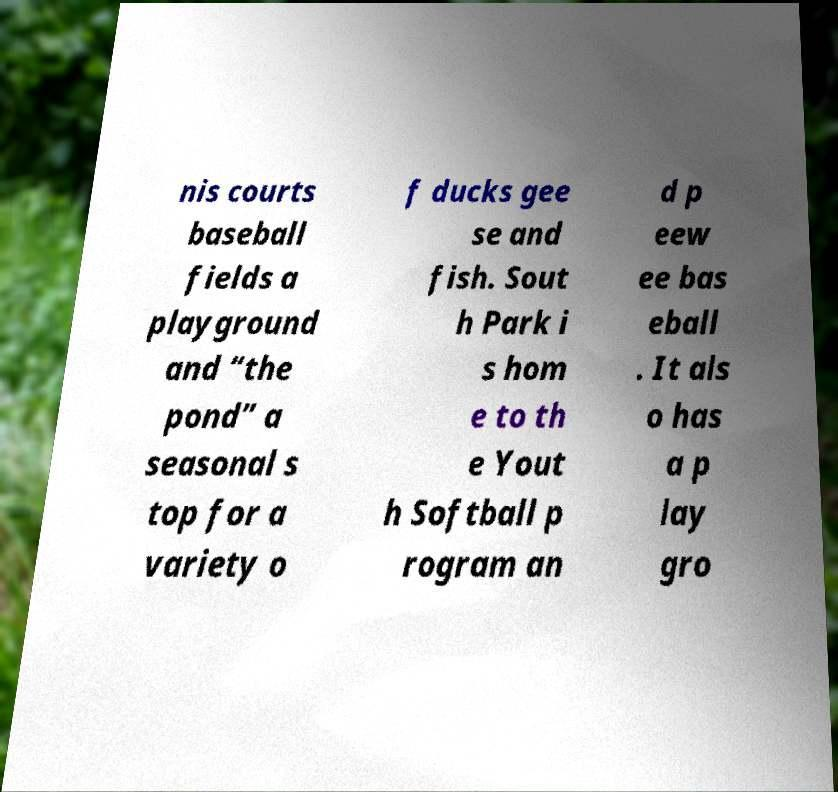I need the written content from this picture converted into text. Can you do that? nis courts baseball fields a playground and “the pond” a seasonal s top for a variety o f ducks gee se and fish. Sout h Park i s hom e to th e Yout h Softball p rogram an d p eew ee bas eball . It als o has a p lay gro 